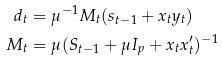Convert formula to latex. <formula><loc_0><loc_0><loc_500><loc_500>d _ { t } & = \mu ^ { - 1 } M _ { t } ( s _ { t - 1 } + x _ { t } y _ { t } ) \\ M _ { t } & = \mu ( S _ { t - 1 } + \mu I _ { p } + x _ { t } x _ { t } ^ { \prime } ) ^ { - 1 }</formula> 